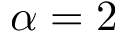<formula> <loc_0><loc_0><loc_500><loc_500>\alpha = 2</formula> 